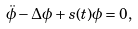<formula> <loc_0><loc_0><loc_500><loc_500>\ddot { \phi } - \Delta \phi + s ( t ) \phi = 0 ,</formula> 